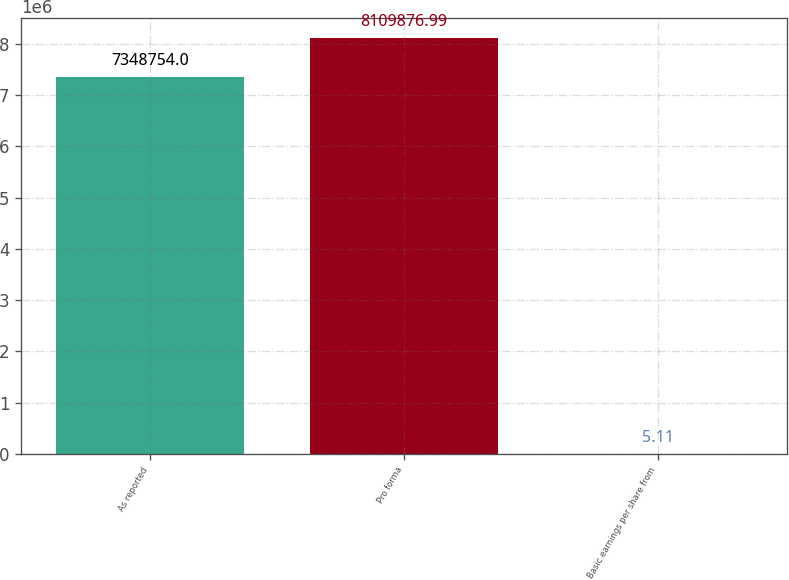<chart> <loc_0><loc_0><loc_500><loc_500><bar_chart><fcel>As reported<fcel>Pro forma<fcel>Basic earnings per share from<nl><fcel>7.34875e+06<fcel>8.10988e+06<fcel>5.11<nl></chart> 